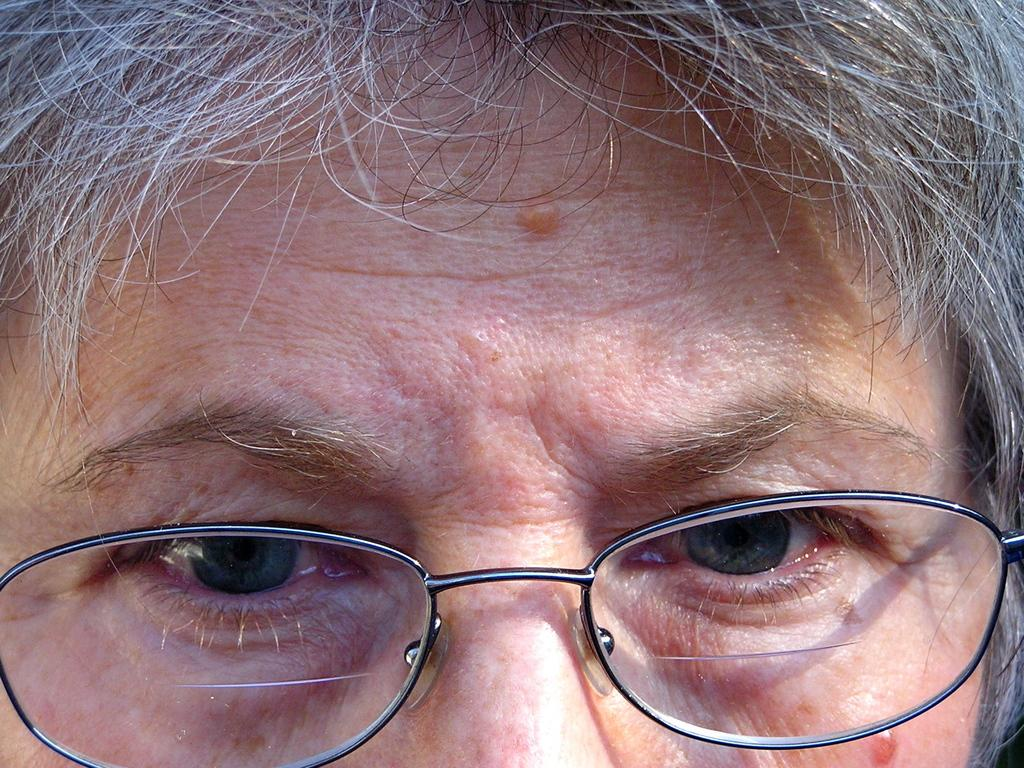What is present in the image? There is a person in the image. Can you describe the person's appearance? The person is wearing glasses. What type of airplane is the person flying in the image? There is no airplane present in the image; it only features a person wearing glasses. How comfortable is the person in the image? The image does not provide any information about the person's comfort level. 